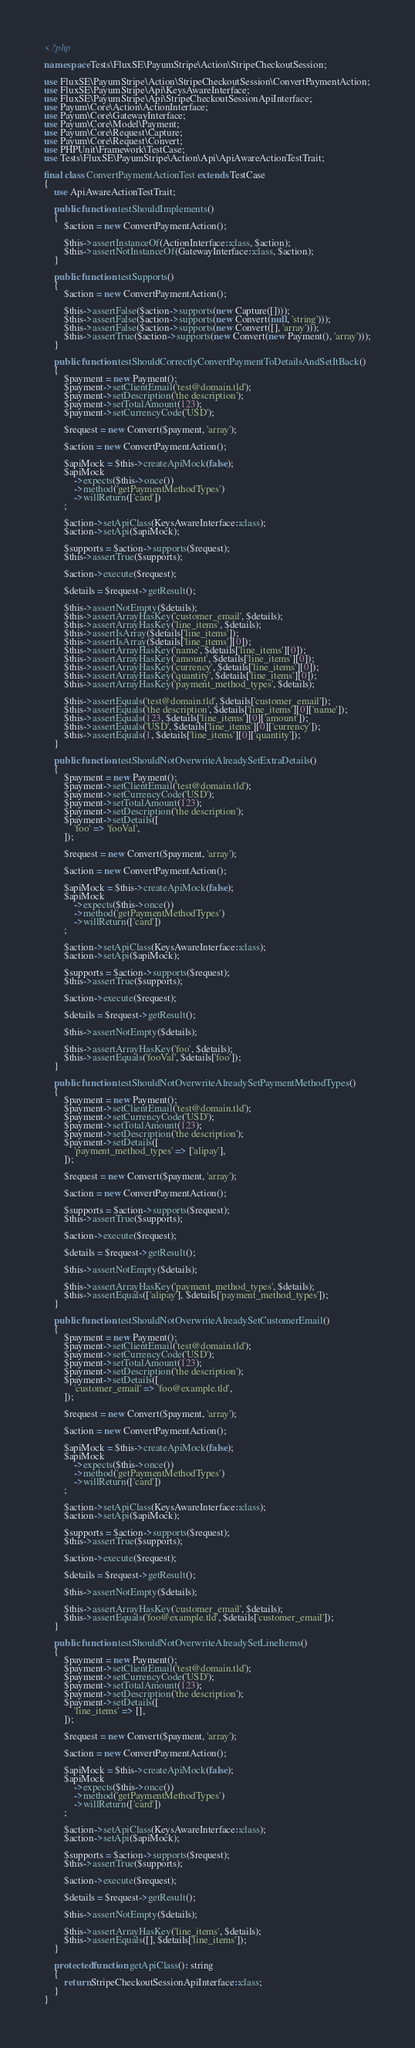<code> <loc_0><loc_0><loc_500><loc_500><_PHP_><?php

namespace Tests\FluxSE\PayumStripe\Action\StripeCheckoutSession;

use FluxSE\PayumStripe\Action\StripeCheckoutSession\ConvertPaymentAction;
use FluxSE\PayumStripe\Api\KeysAwareInterface;
use FluxSE\PayumStripe\Api\StripeCheckoutSessionApiInterface;
use Payum\Core\Action\ActionInterface;
use Payum\Core\GatewayInterface;
use Payum\Core\Model\Payment;
use Payum\Core\Request\Capture;
use Payum\Core\Request\Convert;
use PHPUnit\Framework\TestCase;
use Tests\FluxSE\PayumStripe\Action\Api\ApiAwareActionTestTrait;

final class ConvertPaymentActionTest extends TestCase
{
    use ApiAwareActionTestTrait;

    public function testShouldImplements()
    {
        $action = new ConvertPaymentAction();

        $this->assertInstanceOf(ActionInterface::class, $action);
        $this->assertNotInstanceOf(GatewayInterface::class, $action);
    }

    public function testSupports()
    {
        $action = new ConvertPaymentAction();

        $this->assertFalse($action->supports(new Capture([])));
        $this->assertFalse($action->supports(new Convert(null, 'string')));
        $this->assertFalse($action->supports(new Convert([], 'array')));
        $this->assertTrue($action->supports(new Convert(new Payment(), 'array')));
    }

    public function testShouldCorrectlyConvertPaymentToDetailsAndSetItBack()
    {
        $payment = new Payment();
        $payment->setClientEmail('test@domain.tld');
        $payment->setDescription('the description');
        $payment->setTotalAmount(123);
        $payment->setCurrencyCode('USD');

        $request = new Convert($payment, 'array');

        $action = new ConvertPaymentAction();

        $apiMock = $this->createApiMock(false);
        $apiMock
            ->expects($this->once())
            ->method('getPaymentMethodTypes')
            ->willReturn(['card'])
        ;

        $action->setApiClass(KeysAwareInterface::class);
        $action->setApi($apiMock);

        $supports = $action->supports($request);
        $this->assertTrue($supports);

        $action->execute($request);

        $details = $request->getResult();

        $this->assertNotEmpty($details);
        $this->assertArrayHasKey('customer_email', $details);
        $this->assertArrayHasKey('line_items', $details);
        $this->assertIsArray($details['line_items']);
        $this->assertIsArray($details['line_items'][0]);
        $this->assertArrayHasKey('name', $details['line_items'][0]);
        $this->assertArrayHasKey('amount', $details['line_items'][0]);
        $this->assertArrayHasKey('currency', $details['line_items'][0]);
        $this->assertArrayHasKey('quantity', $details['line_items'][0]);
        $this->assertArrayHasKey('payment_method_types', $details);

        $this->assertEquals('test@domain.tld', $details['customer_email']);
        $this->assertEquals('the description', $details['line_items'][0]['name']);
        $this->assertEquals(123, $details['line_items'][0]['amount']);
        $this->assertEquals('USD', $details['line_items'][0]['currency']);
        $this->assertEquals(1, $details['line_items'][0]['quantity']);
    }

    public function testShouldNotOverwriteAlreadySetExtraDetails()
    {
        $payment = new Payment();
        $payment->setClientEmail('test@domain.tld');
        $payment->setCurrencyCode('USD');
        $payment->setTotalAmount(123);
        $payment->setDescription('the description');
        $payment->setDetails([
            'foo' => 'fooVal',
        ]);

        $request = new Convert($payment, 'array');

        $action = new ConvertPaymentAction();

        $apiMock = $this->createApiMock(false);
        $apiMock
            ->expects($this->once())
            ->method('getPaymentMethodTypes')
            ->willReturn(['card'])
        ;

        $action->setApiClass(KeysAwareInterface::class);
        $action->setApi($apiMock);

        $supports = $action->supports($request);
        $this->assertTrue($supports);

        $action->execute($request);

        $details = $request->getResult();

        $this->assertNotEmpty($details);

        $this->assertArrayHasKey('foo', $details);
        $this->assertEquals('fooVal', $details['foo']);
    }

    public function testShouldNotOverwriteAlreadySetPaymentMethodTypes()
    {
        $payment = new Payment();
        $payment->setClientEmail('test@domain.tld');
        $payment->setCurrencyCode('USD');
        $payment->setTotalAmount(123);
        $payment->setDescription('the description');
        $payment->setDetails([
            'payment_method_types' => ['alipay'],
        ]);

        $request = new Convert($payment, 'array');

        $action = new ConvertPaymentAction();

        $supports = $action->supports($request);
        $this->assertTrue($supports);

        $action->execute($request);

        $details = $request->getResult();

        $this->assertNotEmpty($details);

        $this->assertArrayHasKey('payment_method_types', $details);
        $this->assertEquals(['alipay'], $details['payment_method_types']);
    }

    public function testShouldNotOverwriteAlreadySetCustomerEmail()
    {
        $payment = new Payment();
        $payment->setClientEmail('test@domain.tld');
        $payment->setCurrencyCode('USD');
        $payment->setTotalAmount(123);
        $payment->setDescription('the description');
        $payment->setDetails([
            'customer_email' => 'foo@example.tld',
        ]);

        $request = new Convert($payment, 'array');

        $action = new ConvertPaymentAction();

        $apiMock = $this->createApiMock(false);
        $apiMock
            ->expects($this->once())
            ->method('getPaymentMethodTypes')
            ->willReturn(['card'])
        ;

        $action->setApiClass(KeysAwareInterface::class);
        $action->setApi($apiMock);

        $supports = $action->supports($request);
        $this->assertTrue($supports);

        $action->execute($request);

        $details = $request->getResult();

        $this->assertNotEmpty($details);

        $this->assertArrayHasKey('customer_email', $details);
        $this->assertEquals('foo@example.tld', $details['customer_email']);
    }

    public function testShouldNotOverwriteAlreadySetLineItems()
    {
        $payment = new Payment();
        $payment->setClientEmail('test@domain.tld');
        $payment->setCurrencyCode('USD');
        $payment->setTotalAmount(123);
        $payment->setDescription('the description');
        $payment->setDetails([
            'line_items' => [],
        ]);

        $request = new Convert($payment, 'array');

        $action = new ConvertPaymentAction();

        $apiMock = $this->createApiMock(false);
        $apiMock
            ->expects($this->once())
            ->method('getPaymentMethodTypes')
            ->willReturn(['card'])
        ;

        $action->setApiClass(KeysAwareInterface::class);
        $action->setApi($apiMock);

        $supports = $action->supports($request);
        $this->assertTrue($supports);

        $action->execute($request);

        $details = $request->getResult();

        $this->assertNotEmpty($details);

        $this->assertArrayHasKey('line_items', $details);
        $this->assertEquals([], $details['line_items']);
    }

    protected function getApiClass(): string
    {
        return StripeCheckoutSessionApiInterface::class;
    }
}
</code> 